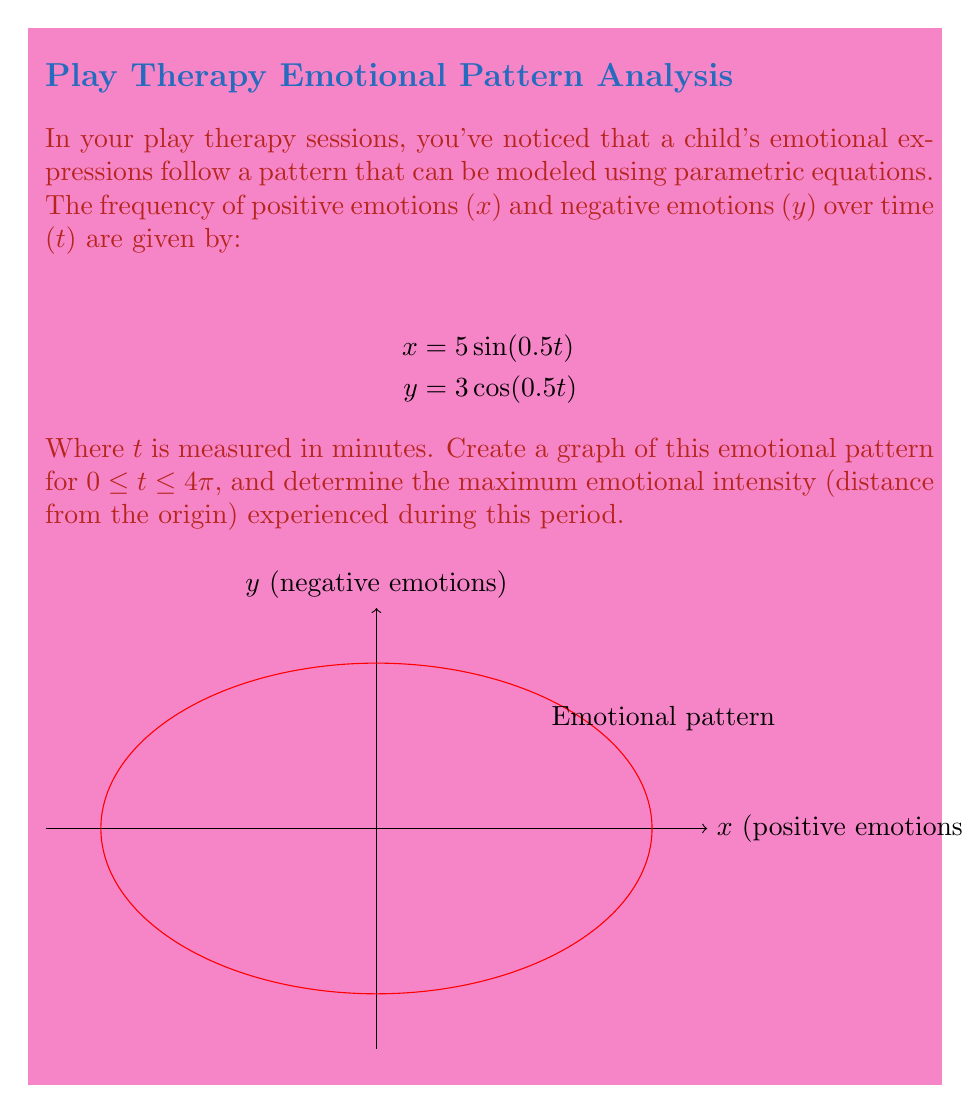Can you answer this question? To solve this problem, we'll follow these steps:

1) First, let's understand what the graph represents. The parametric equations describe the child's emotional state over time, with x representing positive emotions and y representing negative emotions.

2) The graph forms an ellipse because it's a combination of sine and cosine functions with different amplitudes.

3) To find the maximum emotional intensity, we need to find the maximum distance from the origin (0,0) to any point on the ellipse. This is equivalent to finding the semi-major axis of the ellipse.

4) For a parametric equation in the form:
   $$x = a\cos(t)$$
   $$y = b\sin(t)$$
   The semi-major axis is the larger of a and b.

5) Our equations are in a slightly different form, but we can identify that:
   $$a = 5$$ (coefficient of sine in x equation)
   $$b = 3$$ (coefficient of cosine in y equation)

6) Since 5 > 3, the semi-major axis is 5.

7) Therefore, the maximum distance from the origin, which represents the maximum emotional intensity, is 5.
Answer: 5 